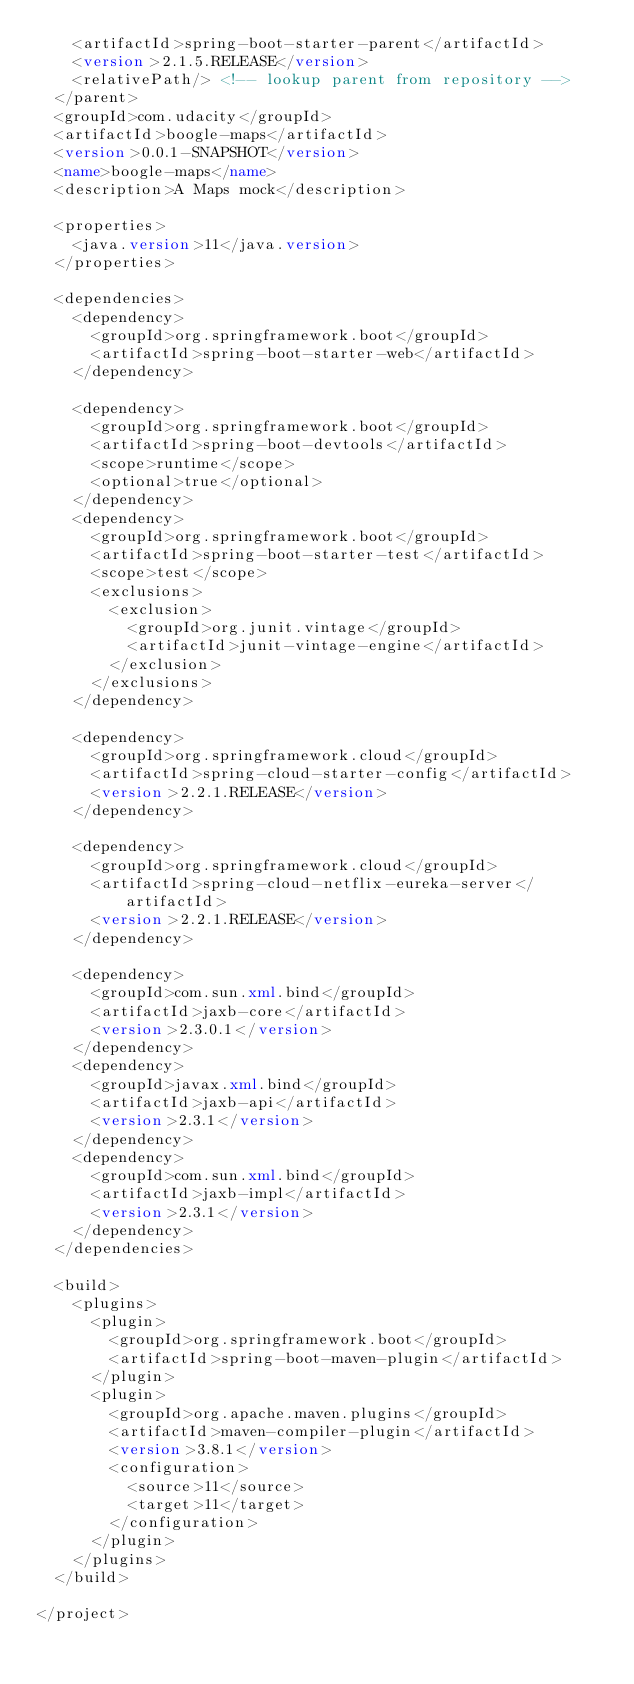<code> <loc_0><loc_0><loc_500><loc_500><_XML_>		<artifactId>spring-boot-starter-parent</artifactId>
		<version>2.1.5.RELEASE</version>
		<relativePath/> <!-- lookup parent from repository -->
	</parent>
	<groupId>com.udacity</groupId>
	<artifactId>boogle-maps</artifactId>
	<version>0.0.1-SNAPSHOT</version>
	<name>boogle-maps</name>
	<description>A Maps mock</description>

	<properties>
		<java.version>11</java.version>
	</properties>

	<dependencies>
		<dependency>
			<groupId>org.springframework.boot</groupId>
			<artifactId>spring-boot-starter-web</artifactId>
		</dependency>

		<dependency>
			<groupId>org.springframework.boot</groupId>
			<artifactId>spring-boot-devtools</artifactId>
			<scope>runtime</scope>
			<optional>true</optional>
		</dependency>
		<dependency>
			<groupId>org.springframework.boot</groupId>
			<artifactId>spring-boot-starter-test</artifactId>
			<scope>test</scope>
			<exclusions>
				<exclusion>
					<groupId>org.junit.vintage</groupId>
					<artifactId>junit-vintage-engine</artifactId>
				</exclusion>
			</exclusions>
		</dependency>

		<dependency>
			<groupId>org.springframework.cloud</groupId>
			<artifactId>spring-cloud-starter-config</artifactId>
			<version>2.2.1.RELEASE</version>
		</dependency>

		<dependency>
			<groupId>org.springframework.cloud</groupId>
			<artifactId>spring-cloud-netflix-eureka-server</artifactId>
			<version>2.2.1.RELEASE</version>
		</dependency>

		<dependency>
			<groupId>com.sun.xml.bind</groupId>
			<artifactId>jaxb-core</artifactId>
			<version>2.3.0.1</version>
		</dependency>
		<dependency>
			<groupId>javax.xml.bind</groupId>
			<artifactId>jaxb-api</artifactId>
			<version>2.3.1</version>
		</dependency>
		<dependency>
			<groupId>com.sun.xml.bind</groupId>
			<artifactId>jaxb-impl</artifactId>
			<version>2.3.1</version>
		</dependency>
	</dependencies>

	<build>
		<plugins>
			<plugin>
				<groupId>org.springframework.boot</groupId>
				<artifactId>spring-boot-maven-plugin</artifactId>
			</plugin>
			<plugin>
				<groupId>org.apache.maven.plugins</groupId>
				<artifactId>maven-compiler-plugin</artifactId>
				<version>3.8.1</version>
				<configuration>
					<source>11</source>
					<target>11</target>
				</configuration>
			</plugin>
		</plugins>
	</build>

</project>
</code> 